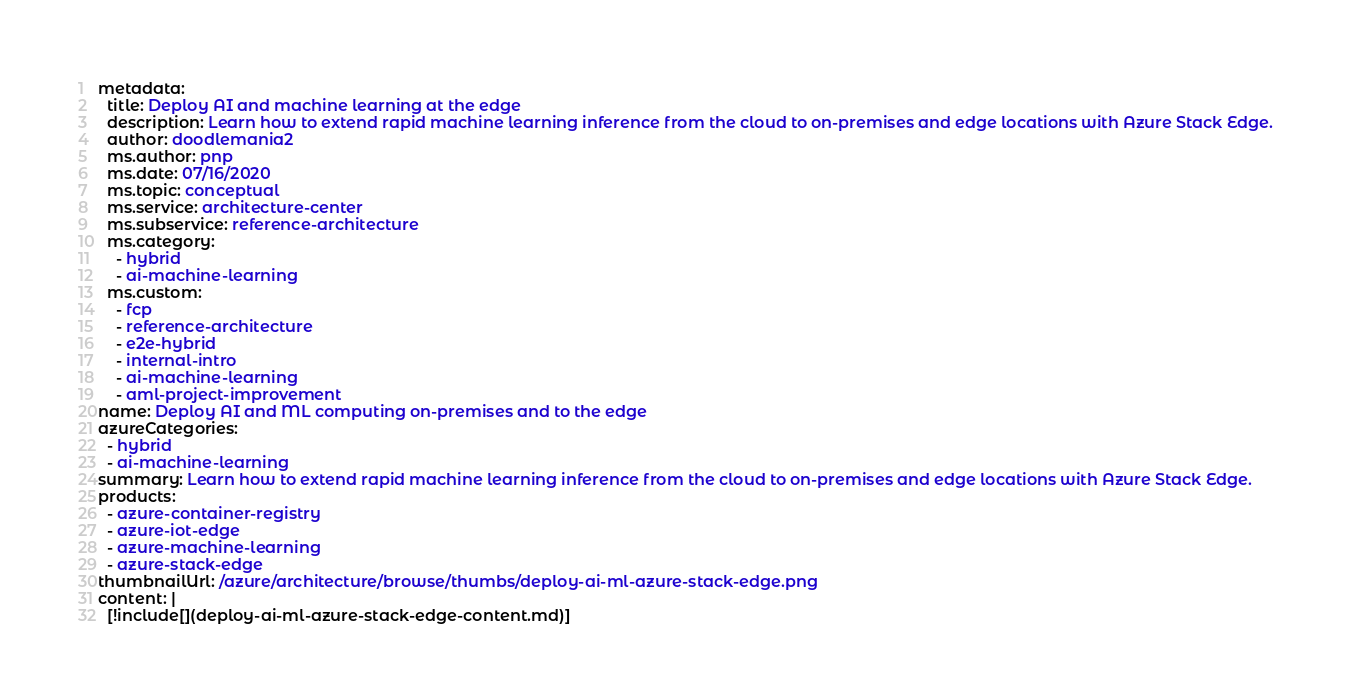<code> <loc_0><loc_0><loc_500><loc_500><_YAML_>metadata:
  title: Deploy AI and machine learning at the edge
  description: Learn how to extend rapid machine learning inference from the cloud to on-premises and edge locations with Azure Stack Edge.
  author: doodlemania2
  ms.author: pnp
  ms.date: 07/16/2020
  ms.topic: conceptual
  ms.service: architecture-center
  ms.subservice: reference-architecture
  ms.category:
    - hybrid
    - ai-machine-learning
  ms.custom:
    - fcp
    - reference-architecture
    - e2e-hybrid
    - internal-intro
    - ai-machine-learning
    - aml-project-improvement
name: Deploy AI and ML computing on-premises and to the edge
azureCategories:
  - hybrid
  - ai-machine-learning
summary: Learn how to extend rapid machine learning inference from the cloud to on-premises and edge locations with Azure Stack Edge.
products:
  - azure-container-registry
  - azure-iot-edge
  - azure-machine-learning
  - azure-stack-edge
thumbnailUrl: /azure/architecture/browse/thumbs/deploy-ai-ml-azure-stack-edge.png
content: |
  [!include[](deploy-ai-ml-azure-stack-edge-content.md)]
</code> 